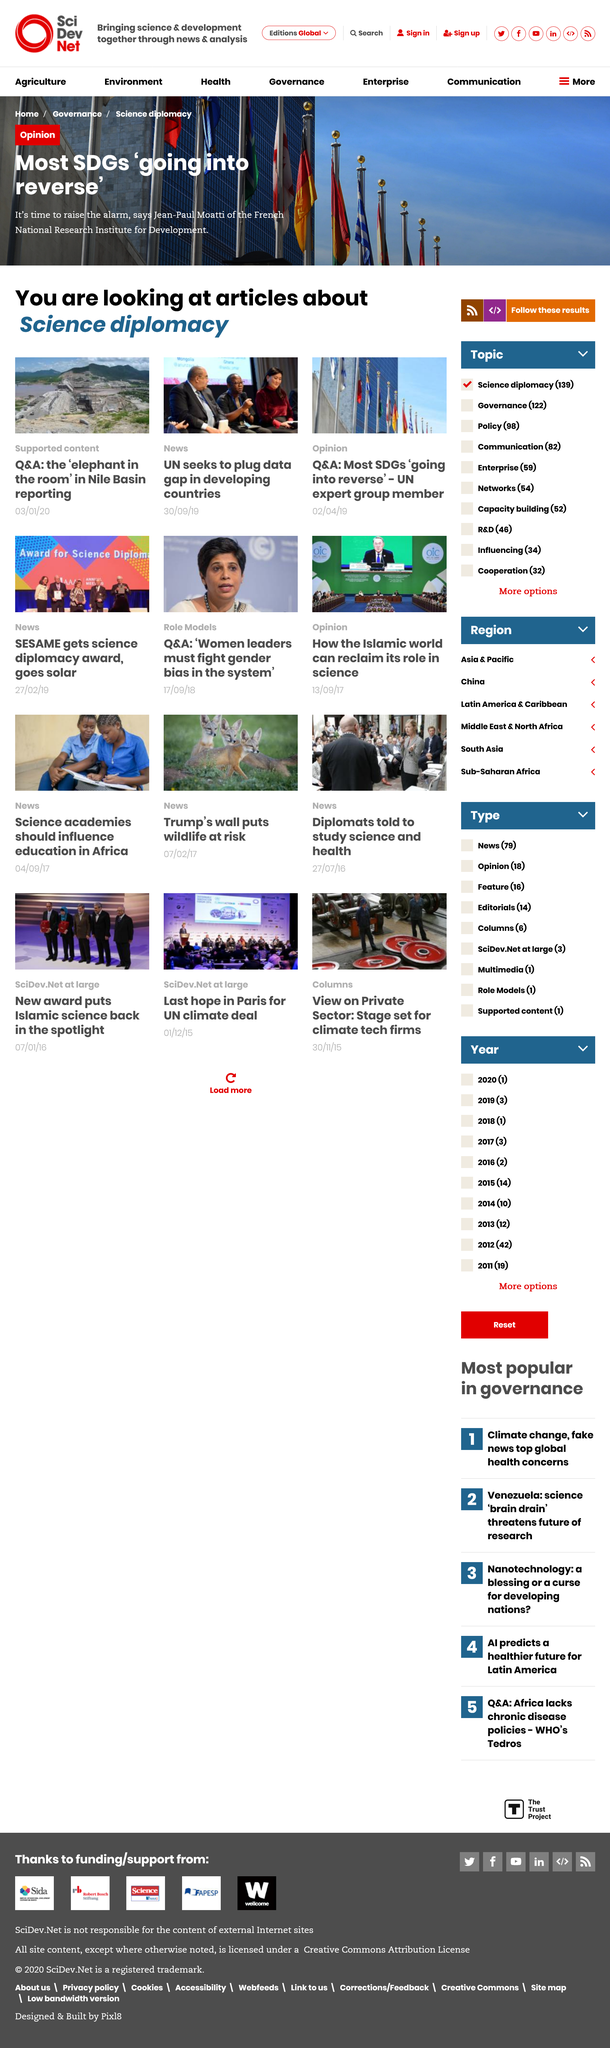Draw attention to some important aspects in this diagram. The article on the UN's efforts to fill the data gap in developing countries falls under the category of news. Jean-Paul Moatti is the one who is raising the alarm and declaring that it is time to do so. Jean-Paul Moatti is a member of the French National Research Institute for Development. 